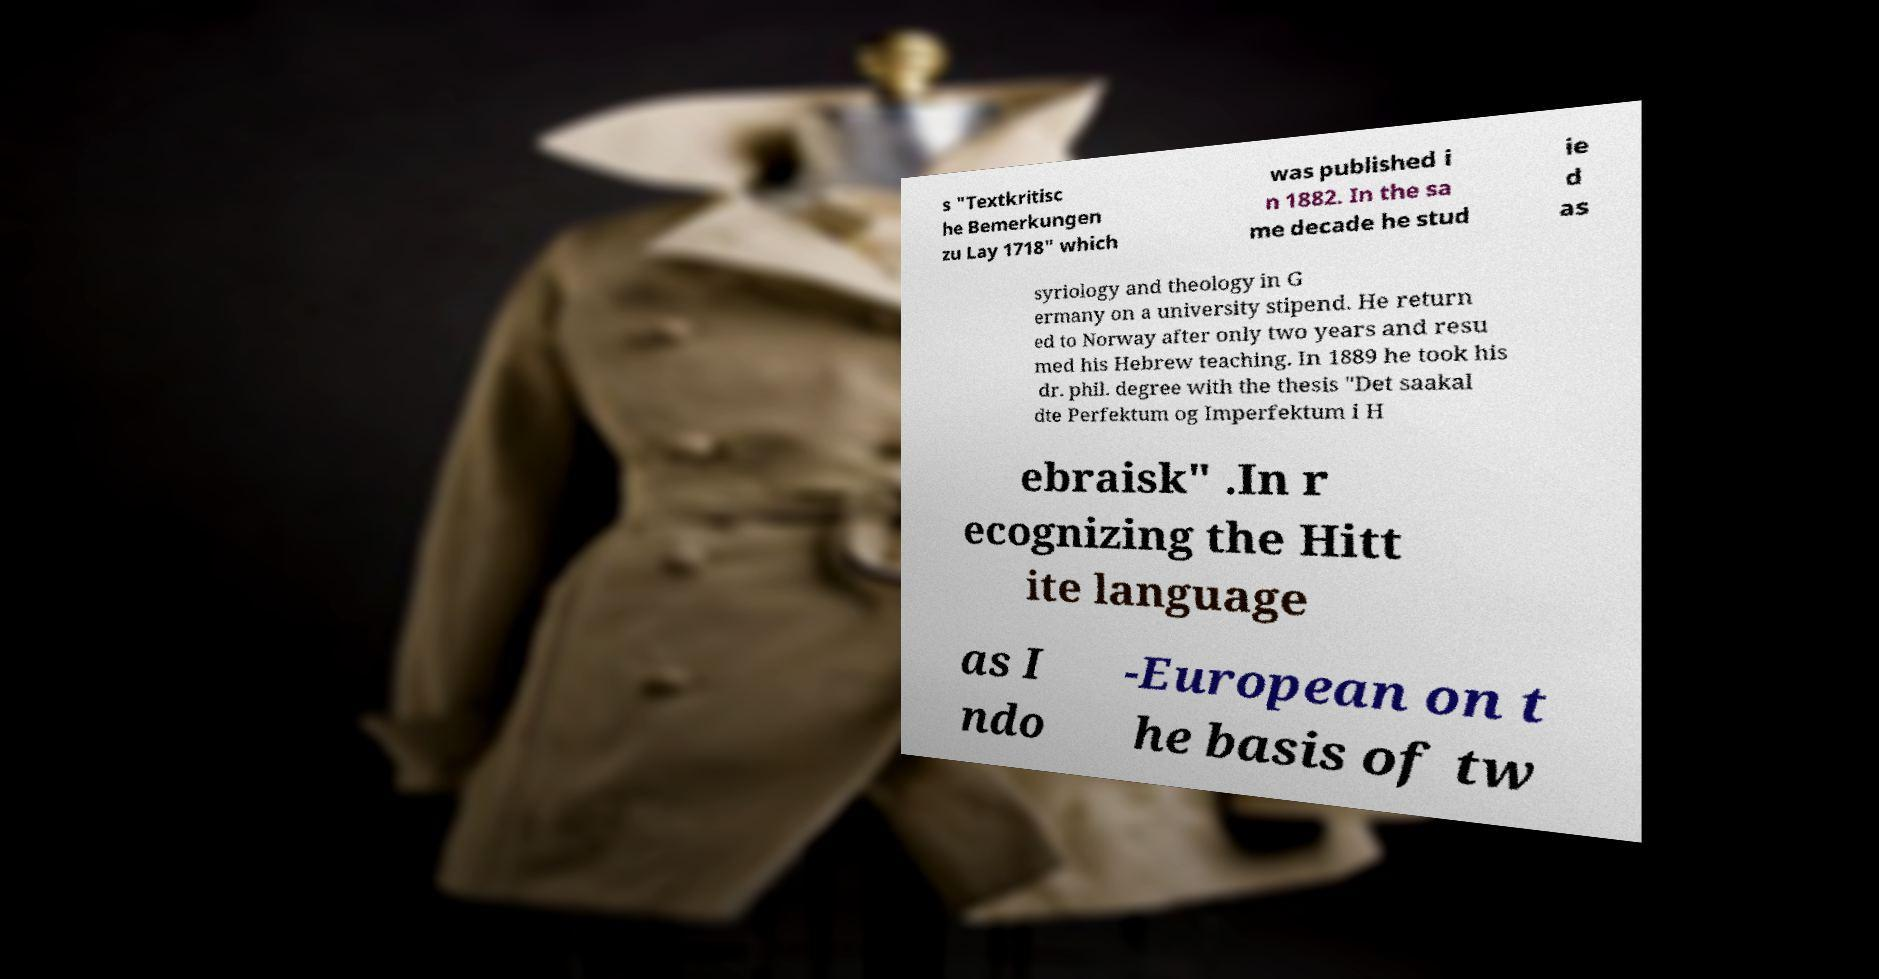Can you accurately transcribe the text from the provided image for me? s "Textkritisc he Bemerkungen zu Lay 1718" which was published i n 1882. In the sa me decade he stud ie d as syriology and theology in G ermany on a university stipend. He return ed to Norway after only two years and resu med his Hebrew teaching. In 1889 he took his dr. phil. degree with the thesis "Det saakal dte Perfektum og Imperfektum i H ebraisk" .In r ecognizing the Hitt ite language as I ndo -European on t he basis of tw 